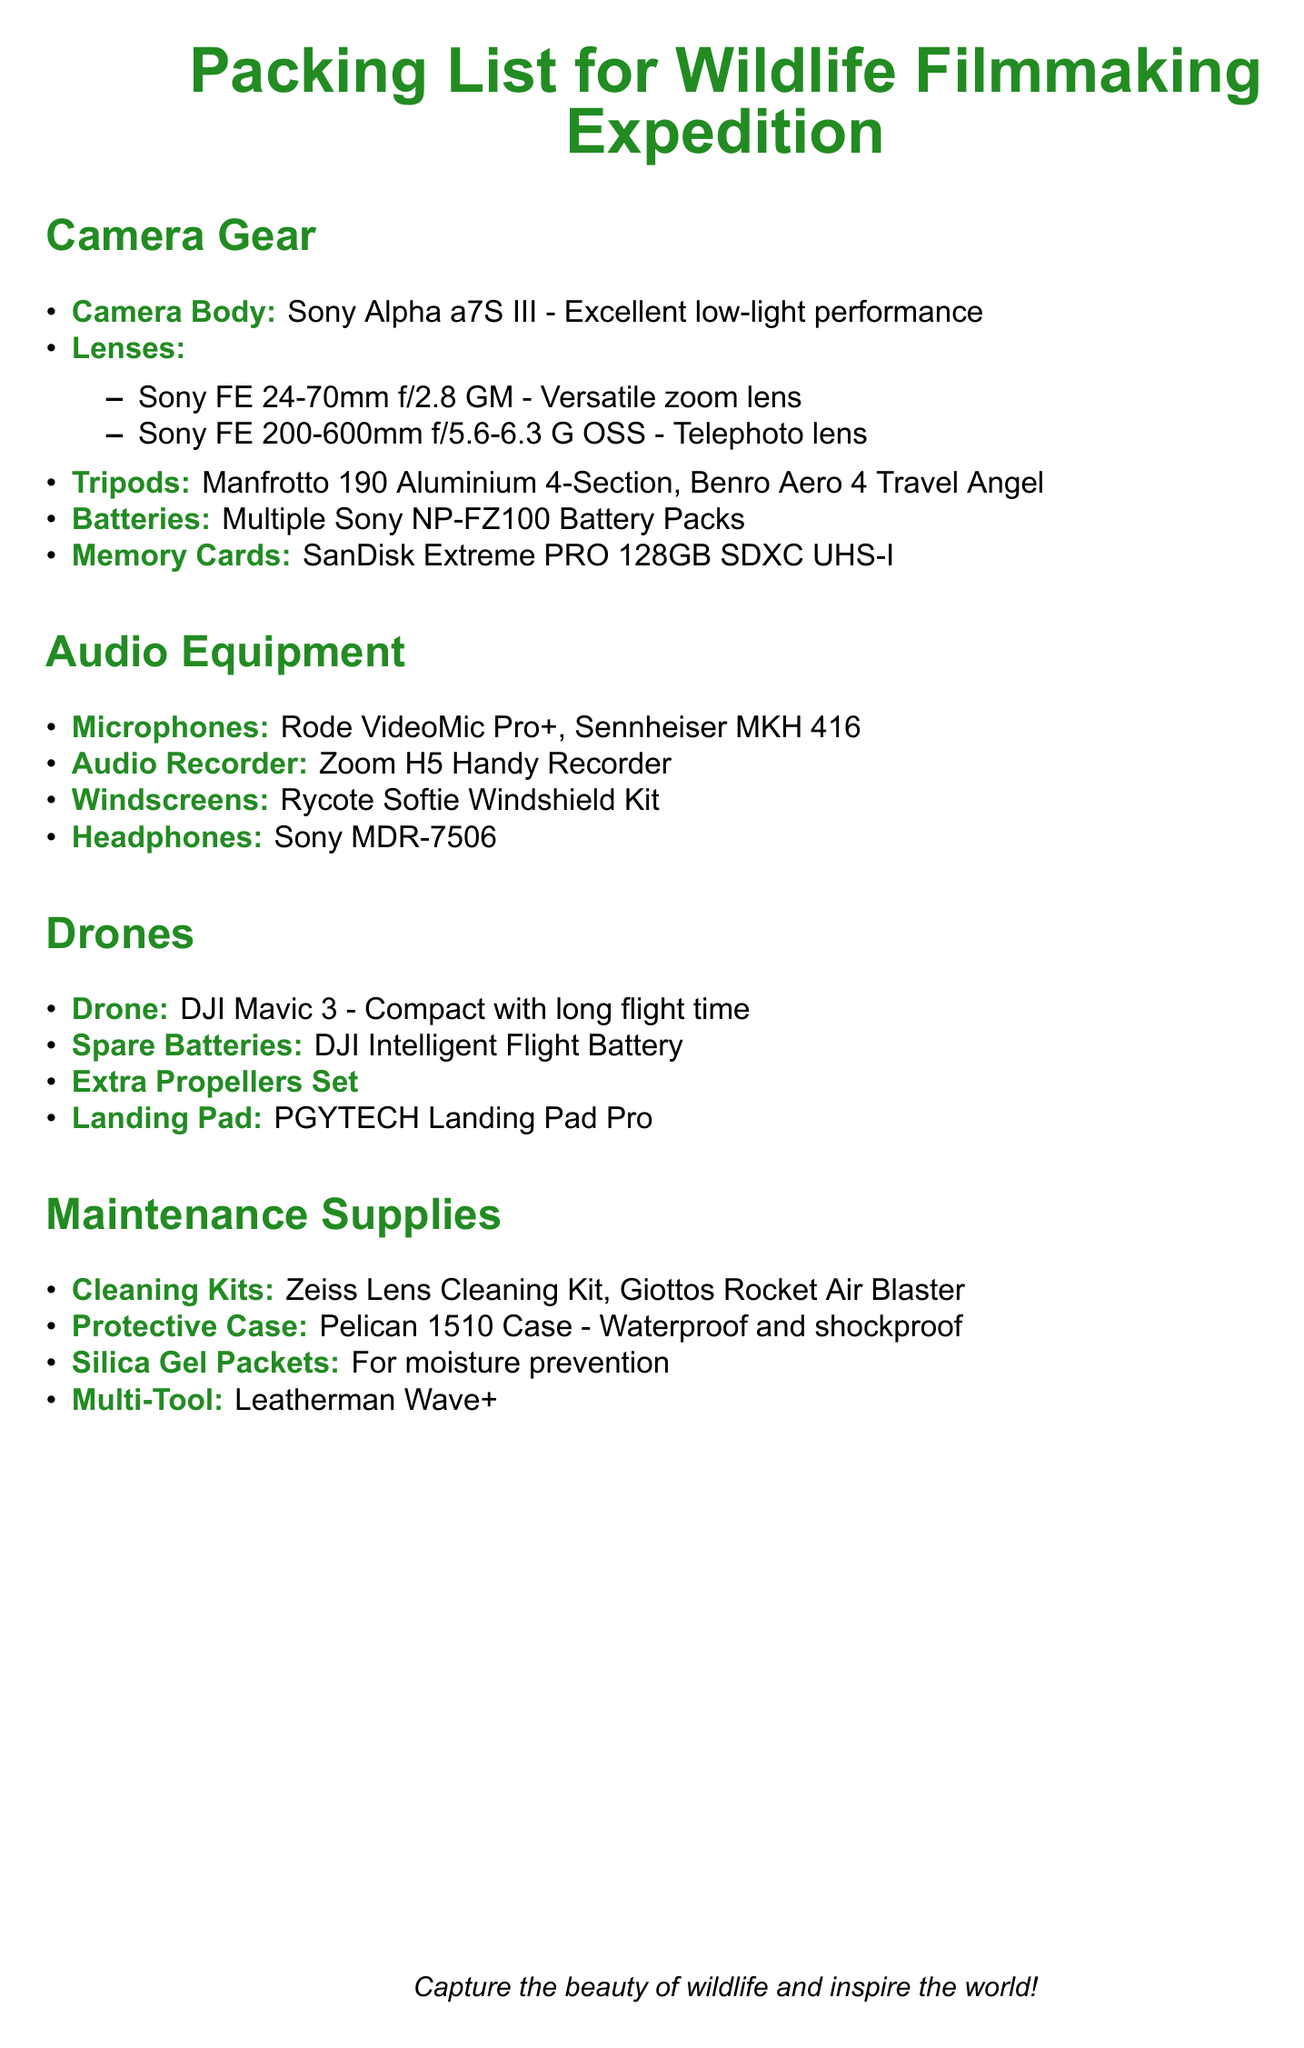What is the recommended camera body? The camera body listed is the Sony Alpha a7S III, noted for its excellent low-light performance.
Answer: Sony Alpha a7S III How many lenses are mentioned in the camera gear section? There are two lenses listed under the camera gear section, which are both specific models.
Answer: 2 What type of drone is included in the packing list? The drone suggested is the DJI Mavic 3, which is described as compact with long flight time.
Answer: DJI Mavic 3 Which audio recorder is specified for the expedition? The audio recorder recommended in the document is the Zoom H5 Handy Recorder.
Answer: Zoom H5 Handy Recorder What is the purpose of the silica gel packets? The silica gel packets are included for moisture prevention during the expedition.
Answer: Moisture prevention How many batteries should be packed for the camera gear? The document mentions multiple batteries, specifying the type required, but does not give a specific number.
Answer: Multiple What cleaning kit is recommended in the maintenance supplies? The mentioned cleaning kit is the Zeiss Lens Cleaning Kit.
Answer: Zeiss Lens Cleaning Kit What is the purpose of the Pelican 1510 Case listed in maintenance supplies? The Pelican 1510 Case is noted as waterproof and shockproof, serving to protect equipment.
Answer: Waterproof and shockproof What is the total number of spare batteries mentioned for the drone? One spare battery type is mentioned specifically, which corresponds to the drone's requirements.
Answer: 1 